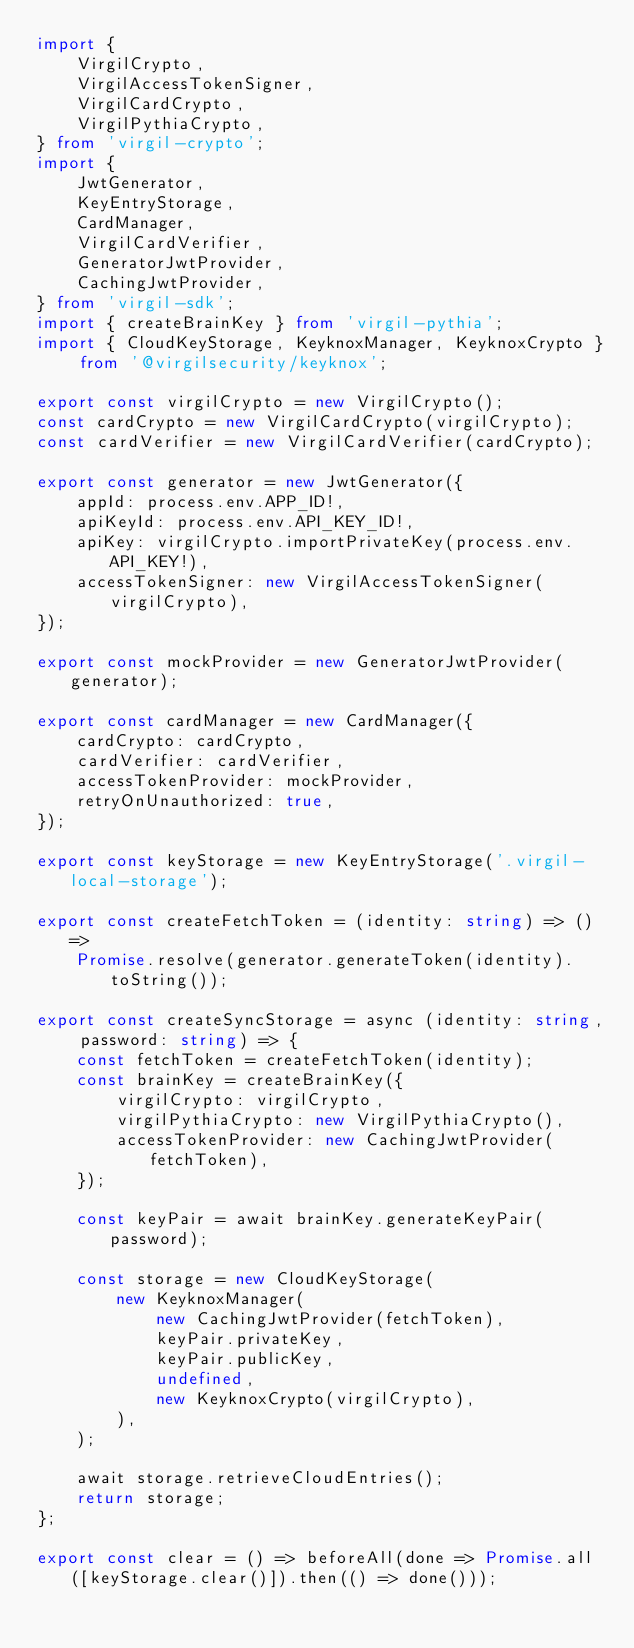Convert code to text. <code><loc_0><loc_0><loc_500><loc_500><_TypeScript_>import {
    VirgilCrypto,
    VirgilAccessTokenSigner,
    VirgilCardCrypto,
    VirgilPythiaCrypto,
} from 'virgil-crypto';
import {
    JwtGenerator,
    KeyEntryStorage,
    CardManager,
    VirgilCardVerifier,
    GeneratorJwtProvider,
    CachingJwtProvider,
} from 'virgil-sdk';
import { createBrainKey } from 'virgil-pythia';
import { CloudKeyStorage, KeyknoxManager, KeyknoxCrypto } from '@virgilsecurity/keyknox';

export const virgilCrypto = new VirgilCrypto();
const cardCrypto = new VirgilCardCrypto(virgilCrypto);
const cardVerifier = new VirgilCardVerifier(cardCrypto);

export const generator = new JwtGenerator({
    appId: process.env.APP_ID!,
    apiKeyId: process.env.API_KEY_ID!,
    apiKey: virgilCrypto.importPrivateKey(process.env.API_KEY!),
    accessTokenSigner: new VirgilAccessTokenSigner(virgilCrypto),
});

export const mockProvider = new GeneratorJwtProvider(generator);

export const cardManager = new CardManager({
    cardCrypto: cardCrypto,
    cardVerifier: cardVerifier,
    accessTokenProvider: mockProvider,
    retryOnUnauthorized: true,
});

export const keyStorage = new KeyEntryStorage('.virgil-local-storage');

export const createFetchToken = (identity: string) => () =>
    Promise.resolve(generator.generateToken(identity).toString());

export const createSyncStorage = async (identity: string, password: string) => {
    const fetchToken = createFetchToken(identity);
    const brainKey = createBrainKey({
        virgilCrypto: virgilCrypto,
        virgilPythiaCrypto: new VirgilPythiaCrypto(),
        accessTokenProvider: new CachingJwtProvider(fetchToken),
    });

    const keyPair = await brainKey.generateKeyPair(password);

    const storage = new CloudKeyStorage(
        new KeyknoxManager(
            new CachingJwtProvider(fetchToken),
            keyPair.privateKey,
            keyPair.publicKey,
            undefined,
            new KeyknoxCrypto(virgilCrypto),
        ),
    );

    await storage.retrieveCloudEntries();
    return storage;
};

export const clear = () => beforeAll(done => Promise.all([keyStorage.clear()]).then(() => done()));
</code> 